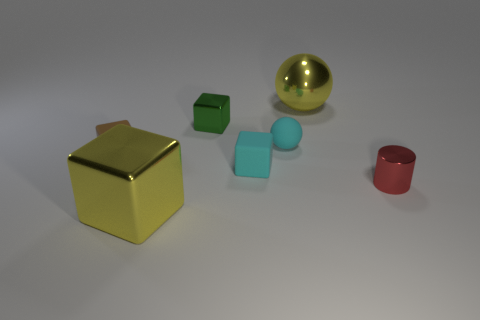Is there anything else that has the same shape as the small red metallic object?
Offer a terse response. No. Do the large thing to the left of the tiny cyan cube and the sphere in front of the metallic sphere have the same material?
Your answer should be compact. No. What is the tiny green thing made of?
Give a very brief answer. Metal. How many other large objects are the same material as the green thing?
Make the answer very short. 2. How many matte things are small red balls or brown blocks?
Your answer should be compact. 1. There is a yellow metallic object to the left of the yellow metallic sphere; is it the same shape as the matte thing on the left side of the green block?
Offer a very short reply. Yes. There is a metal object that is on the right side of the small green object and in front of the big yellow shiny sphere; what color is it?
Your answer should be compact. Red. There is a cyan rubber object that is in front of the brown block; is its size the same as the yellow shiny thing on the right side of the cyan rubber block?
Offer a very short reply. No. What number of shiny objects are the same color as the big sphere?
Offer a terse response. 1. What number of tiny objects are either cylinders or green metal cubes?
Give a very brief answer. 2. 